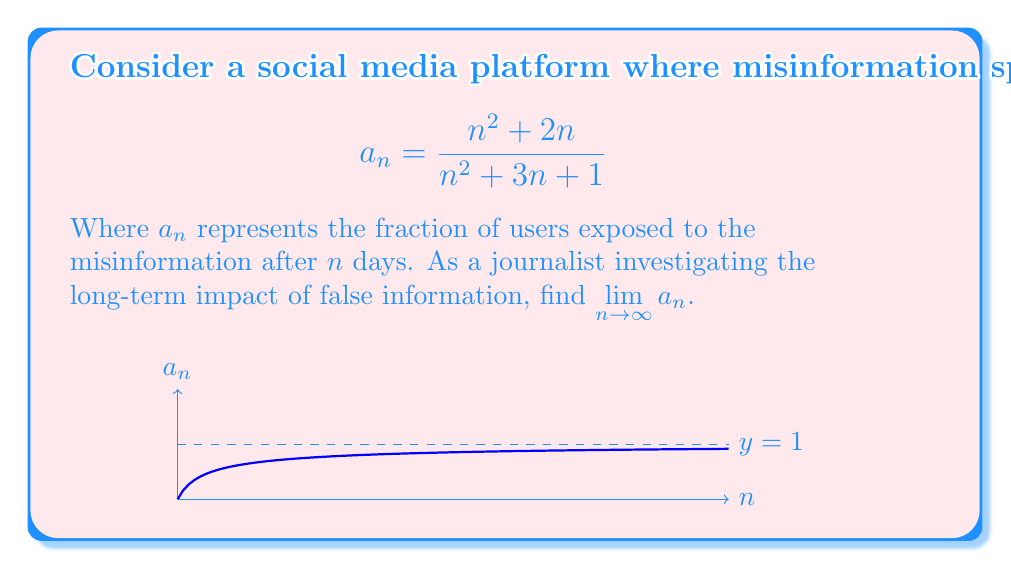Help me with this question. To find the limit of this sequence as $n$ approaches infinity, we can follow these steps:

1) First, let's examine the highest degree terms in the numerator and denominator:
   $$\lim_{n \to \infty} \frac{n^2 + 2n}{n^2 + 3n + 1}$$

2) Both the numerator and denominator have $n^2$ as the highest degree term.

3) We can factor out $n^2$ from both:
   $$\lim_{n \to \infty} \frac{n^2(1 + \frac{2}{n})}{n^2(1 + \frac{3}{n} + \frac{1}{n^2})}$$

4) The $n^2$ terms cancel out:
   $$\lim_{n \to \infty} \frac{1 + \frac{2}{n}}{1 + \frac{3}{n} + \frac{1}{n^2}}$$

5) As $n$ approaches infinity, $\frac{1}{n}$ and $\frac{1}{n^2}$ approach 0:
   $$\lim_{n \to \infty} \frac{1 + 0}{1 + 0 + 0} = \frac{1}{1} = 1$$

This result suggests that in the long run, the misinformation would potentially reach all users on the platform, highlighting the importance of fact-checking and responsible information sharing.
Answer: $1$ 